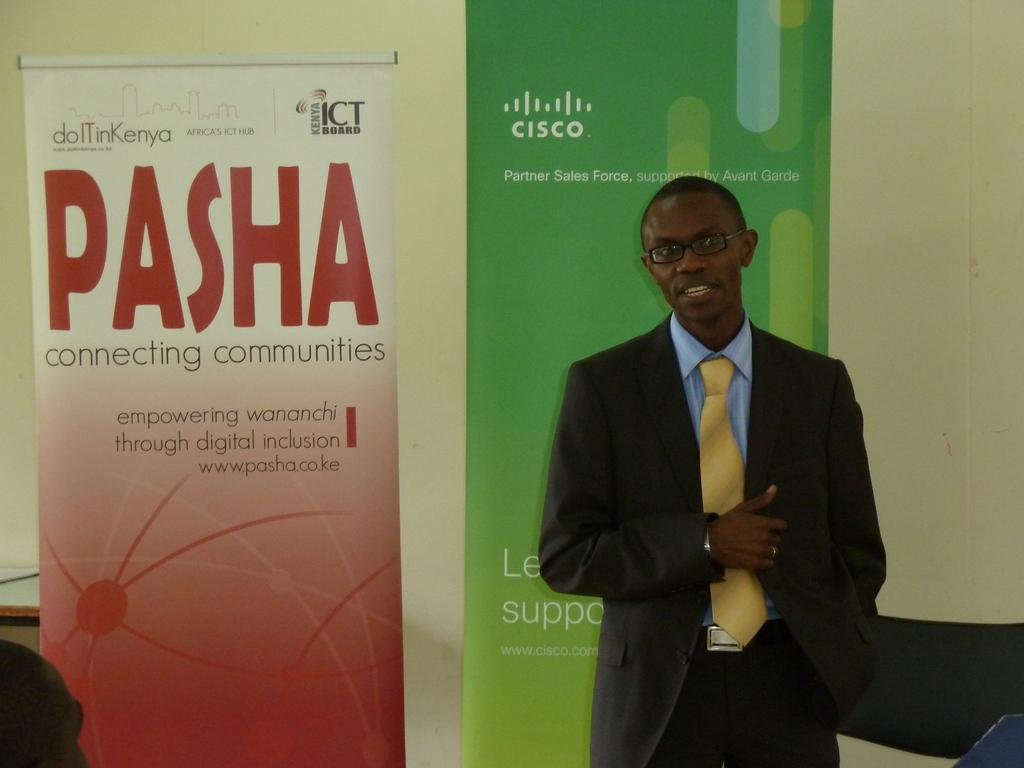<image>
Describe the image concisely. Join a PASHA meeting and start connecting communities 